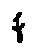Convert formula to latex. <formula><loc_0><loc_0><loc_500><loc_500>f</formula> 